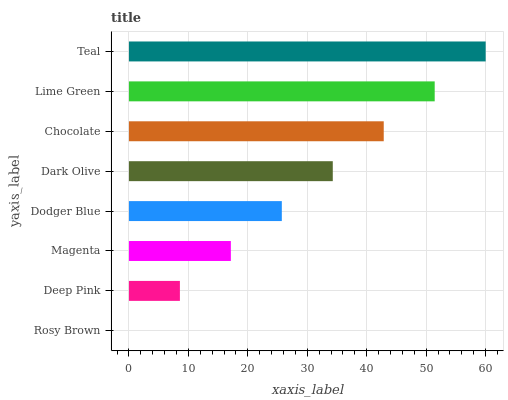Is Rosy Brown the minimum?
Answer yes or no. Yes. Is Teal the maximum?
Answer yes or no. Yes. Is Deep Pink the minimum?
Answer yes or no. No. Is Deep Pink the maximum?
Answer yes or no. No. Is Deep Pink greater than Rosy Brown?
Answer yes or no. Yes. Is Rosy Brown less than Deep Pink?
Answer yes or no. Yes. Is Rosy Brown greater than Deep Pink?
Answer yes or no. No. Is Deep Pink less than Rosy Brown?
Answer yes or no. No. Is Dark Olive the high median?
Answer yes or no. Yes. Is Dodger Blue the low median?
Answer yes or no. Yes. Is Rosy Brown the high median?
Answer yes or no. No. Is Chocolate the low median?
Answer yes or no. No. 